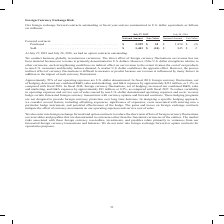From Cisco Systems's financial document, Which years does the table provide information for the company's foreign exchange forward contracts outstanding at fiscal year-end? The document shows two values: 2019 and 2018. From the document: "July 27, 2019 July 28, 2018 July 27, 2019 July 28, 2018..." Also, Why has the direct effect of foreign currency fluctuations on revenue not been material? because our revenue is primarily denominated in U.S. dollars.. The document states: "ency fluctuations on revenue has not been material because our revenue is primarily denominated in U.S. dollars. However, if the U.S. dollar strengthe..." Also, What was the Fair value of purchased forward contracts in 2019? According to the financial document, 14 (in millions). The relevant text states: "r Value Forward contracts: Purchased. . $ 2,239 $ 14 $ 1,850 $ (2) Sold. . $ 1,441 $ (14) $ 845 $ 2..." Also, can you calculate: What was the change in the notional amount of purchased forward contracts between 2018 and 2019? Based on the calculation: 2,239-1,850, the result is 389 (in millions). This is based on the information: "ount Fair Value Forward contracts: Purchased. . $ 2,239 $ 14 $ 1,850 $ (2) Sold. . $ 1,441 $ (14) $ 845 $ 2 ue Forward contracts: Purchased. . $ 2,239 $ 14 $ 1,850 $ (2) Sold. . $ 1,441 $ (14) $ 845 $..." The key data points involved are: 1,850, 2,239. Also, can you calculate: What was the change in the fair value of sold forward contracts between 2018 and 2019? Based on the calculation: -14-2, the result is -16 (in millions). This is based on the information: "r Value Forward contracts: Purchased. . $ 2,239 $ 14 $ 1,850 $ (2) Sold. . $ 1,441 $ (14) $ 845 $ 2 July 27, 2019 July 28, 2018..." The key data points involved are: 14, 2. Also, can you calculate: What was the percentage change in the notional amount of sold forward contracts between 2018 and 2019? To answer this question, I need to perform calculations using the financial data. The calculation is: (1,441-845)/845, which equals 70.53 (percentage). This is based on the information: "2,239 $ 14 $ 1,850 $ (2) Sold. . $ 1,441 $ (14) $ 845 $ 2 Purchased. . $ 2,239 $ 14 $ 1,850 $ (2) Sold. . $ 1,441 $ (14) $ 845 $ 2..." The key data points involved are: 1,441, 845. 